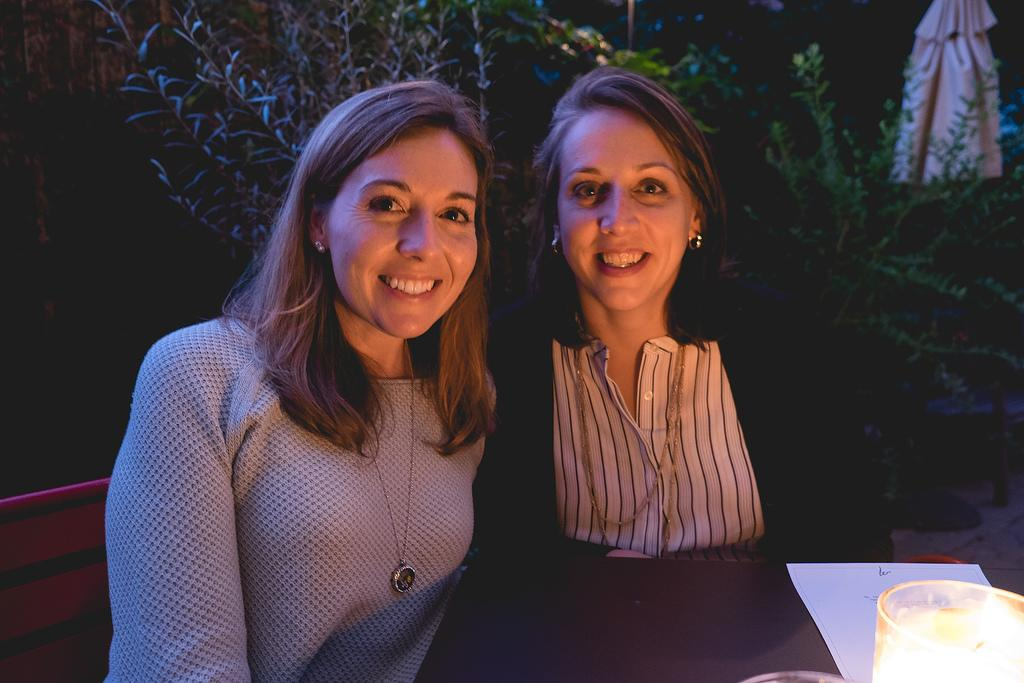How many girls are in the image? There are two girls in the image. Where are the girls located in the image? The girls are sitting in the front. What expression do the girls have in the image? The girls are smiling. What are the girls doing in the image? The girls are giving a pose to the camera. What can be seen in the background of the image? There is a dark background in the image. What type of vegetation is visible in the image? There are plants visible in the image. What type of vessel is the girls using to write in the image? There is no vessel or writing activity present in the image. What time does the watch in the image show? There is no watch present in the image. 